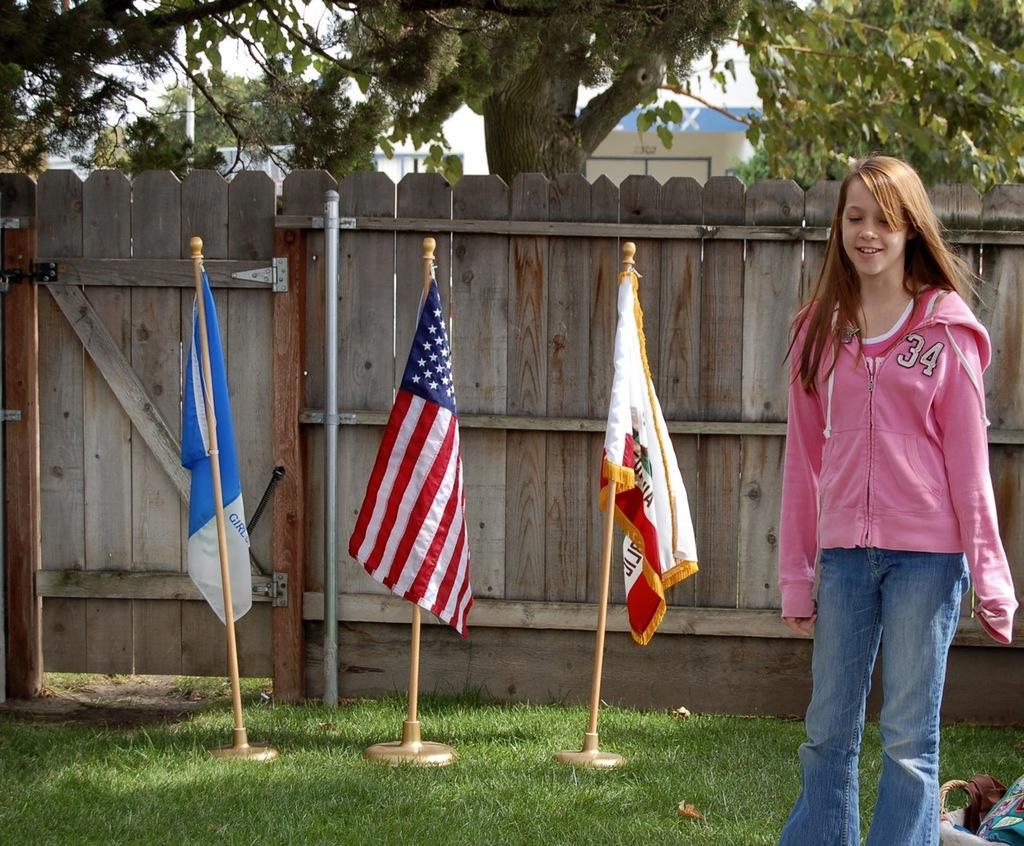Describe this image in one or two sentences. In this image we can see a person standing on the ground, there is a basket with few objects near the person, there are flags, a wooden fence with gate and few trees. 